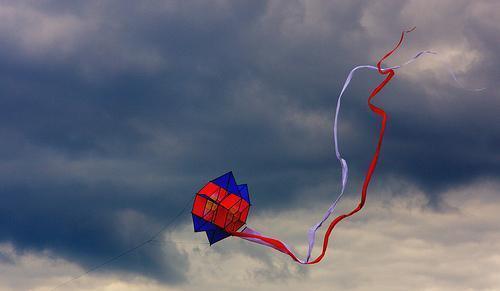How many kites are there?
Give a very brief answer. 1. 